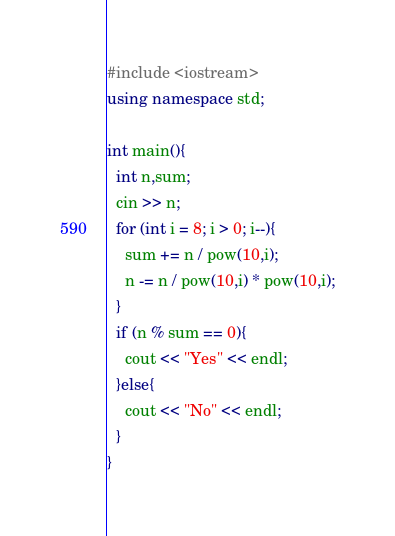<code> <loc_0><loc_0><loc_500><loc_500><_C++_>#include <iostream>
using namespace std;

int main(){
  int n,sum;
  cin >> n;
  for (int i = 8; i > 0; i--){
    sum += n / pow(10,i);
    n -= n / pow(10,i) * pow(10,i);
  }
  if (n % sum == 0){
    cout << "Yes" << endl;
  }else{
    cout << "No" << endl;
  }
}</code> 